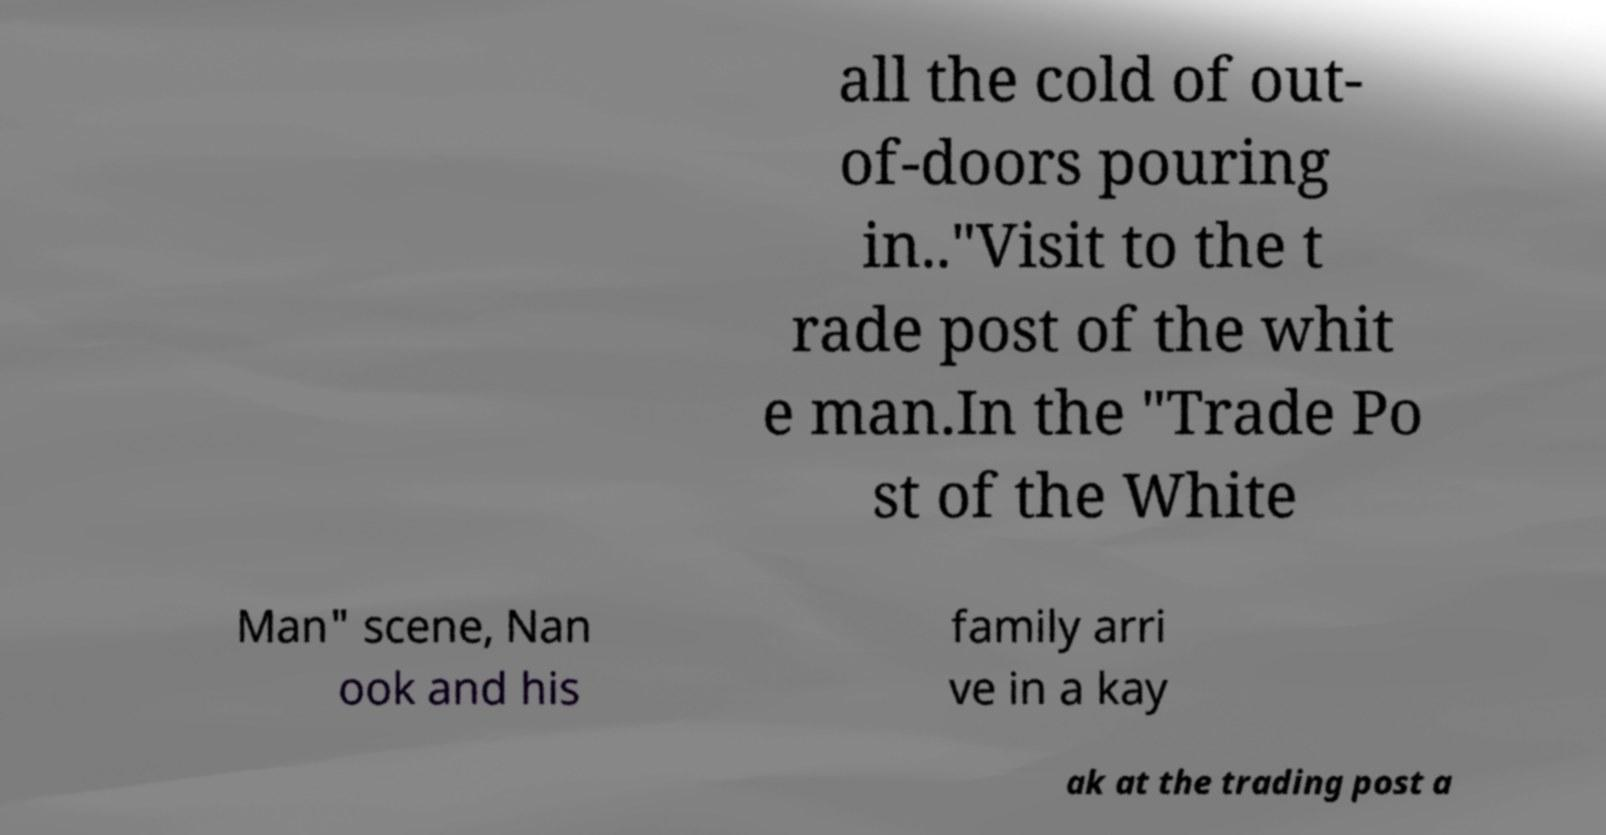Could you assist in decoding the text presented in this image and type it out clearly? all the cold of out- of-doors pouring in.."Visit to the t rade post of the whit e man.In the "Trade Po st of the White Man" scene, Nan ook and his family arri ve in a kay ak at the trading post a 